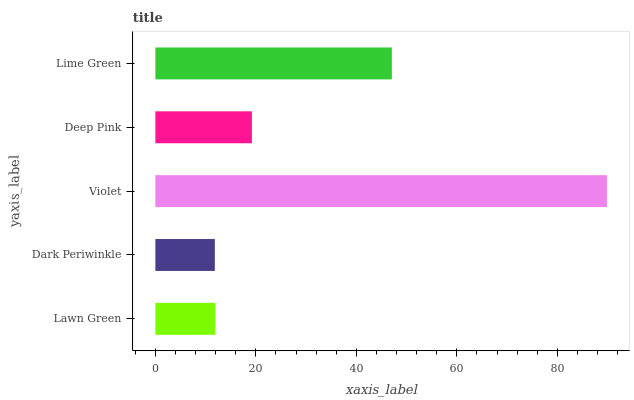Is Dark Periwinkle the minimum?
Answer yes or no. Yes. Is Violet the maximum?
Answer yes or no. Yes. Is Violet the minimum?
Answer yes or no. No. Is Dark Periwinkle the maximum?
Answer yes or no. No. Is Violet greater than Dark Periwinkle?
Answer yes or no. Yes. Is Dark Periwinkle less than Violet?
Answer yes or no. Yes. Is Dark Periwinkle greater than Violet?
Answer yes or no. No. Is Violet less than Dark Periwinkle?
Answer yes or no. No. Is Deep Pink the high median?
Answer yes or no. Yes. Is Deep Pink the low median?
Answer yes or no. Yes. Is Dark Periwinkle the high median?
Answer yes or no. No. Is Lawn Green the low median?
Answer yes or no. No. 